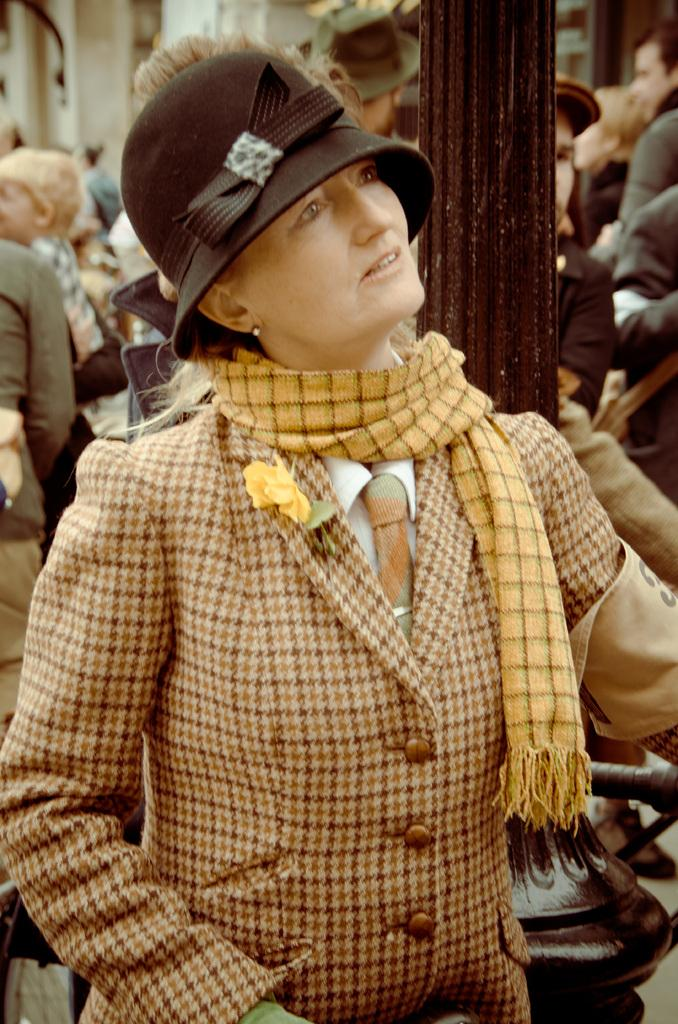Who is the main subject in the foreground of the image? There is a woman in the foreground of the image. What accessories is the woman wearing? The woman is wearing a scarf and a hat. What can be seen in the background of the image? There is a group of people, a pole, and buildings in the background of the image. What type of tree can be seen in the image? There is no tree present in the image. How does the deer interact with the woman in the image? There is no deer present in the image, so it cannot interact with the woman. 